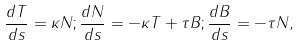Convert formula to latex. <formula><loc_0><loc_0><loc_500><loc_500>\frac { d { T } } { d s } = \kappa { N } ; \frac { d { N } } { d s } = - \kappa { T } + \tau { B } ; \frac { d { B } } { d s } = - \tau { N } ,</formula> 